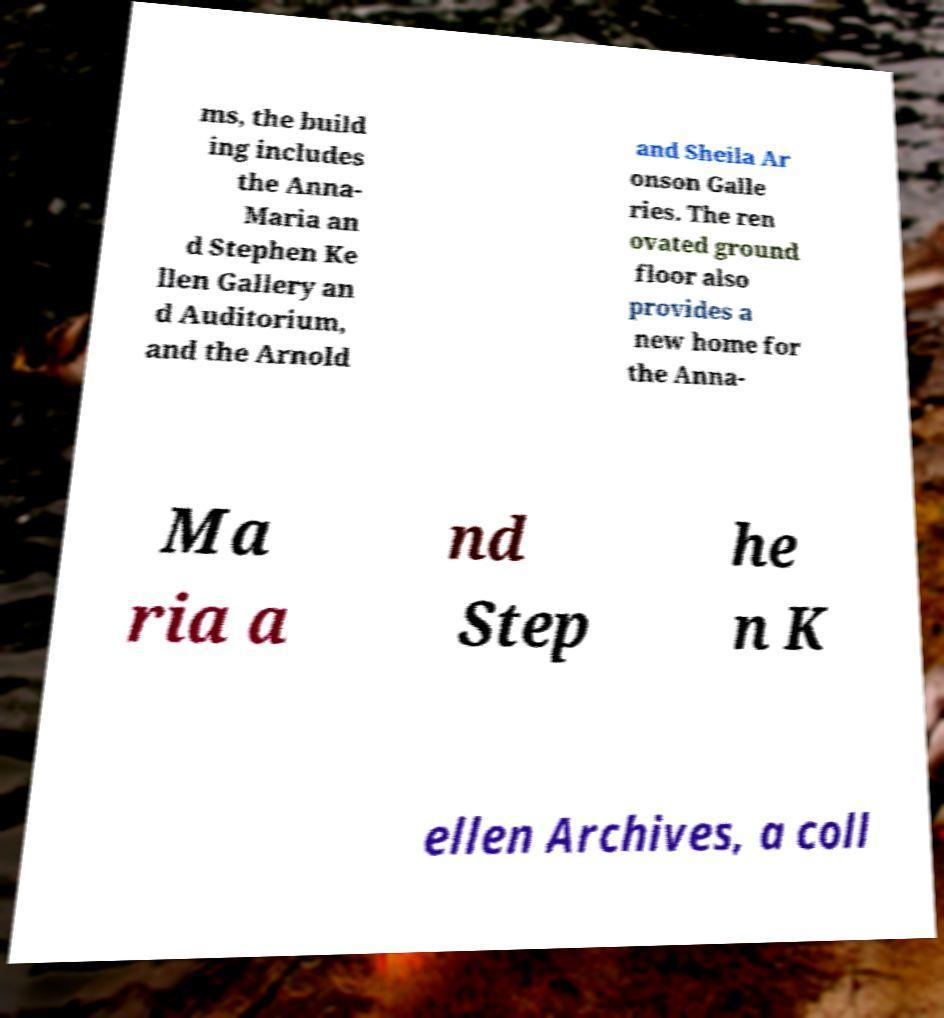Could you assist in decoding the text presented in this image and type it out clearly? ms, the build ing includes the Anna- Maria an d Stephen Ke llen Gallery an d Auditorium, and the Arnold and Sheila Ar onson Galle ries. The ren ovated ground floor also provides a new home for the Anna- Ma ria a nd Step he n K ellen Archives, a coll 